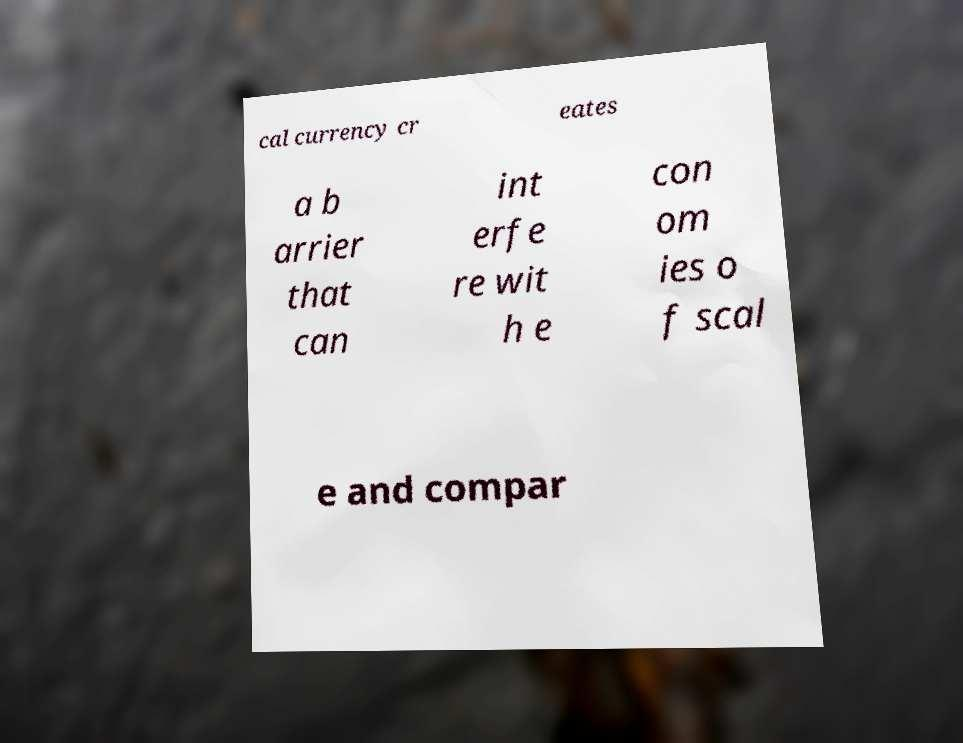What messages or text are displayed in this image? I need them in a readable, typed format. cal currency cr eates a b arrier that can int erfe re wit h e con om ies o f scal e and compar 